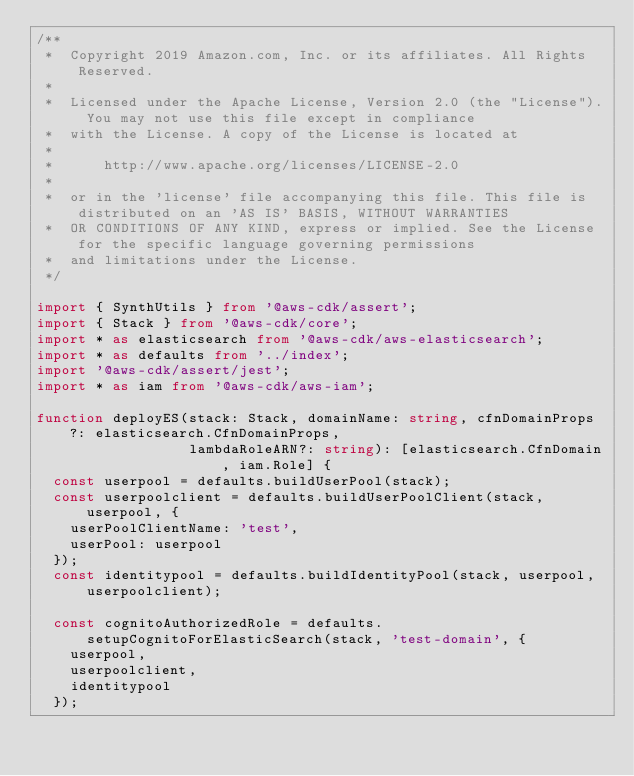<code> <loc_0><loc_0><loc_500><loc_500><_TypeScript_>/**
 *  Copyright 2019 Amazon.com, Inc. or its affiliates. All Rights Reserved.
 *
 *  Licensed under the Apache License, Version 2.0 (the "License"). You may not use this file except in compliance
 *  with the License. A copy of the License is located at
 *
 *      http://www.apache.org/licenses/LICENSE-2.0
 *
 *  or in the 'license' file accompanying this file. This file is distributed on an 'AS IS' BASIS, WITHOUT WARRANTIES
 *  OR CONDITIONS OF ANY KIND, express or implied. See the License for the specific language governing permissions
 *  and limitations under the License.
 */

import { SynthUtils } from '@aws-cdk/assert';
import { Stack } from '@aws-cdk/core';
import * as elasticsearch from '@aws-cdk/aws-elasticsearch';
import * as defaults from '../index';
import '@aws-cdk/assert/jest';
import * as iam from '@aws-cdk/aws-iam';

function deployES(stack: Stack, domainName: string, cfnDomainProps?: elasticsearch.CfnDomainProps,
                  lambdaRoleARN?: string): [elasticsearch.CfnDomain, iam.Role] {
  const userpool = defaults.buildUserPool(stack);
  const userpoolclient = defaults.buildUserPoolClient(stack, userpool, {
    userPoolClientName: 'test',
    userPool: userpool
  });
  const identitypool = defaults.buildIdentityPool(stack, userpool, userpoolclient);

  const cognitoAuthorizedRole = defaults.setupCognitoForElasticSearch(stack, 'test-domain', {
    userpool,
    userpoolclient,
    identitypool
  });
</code> 